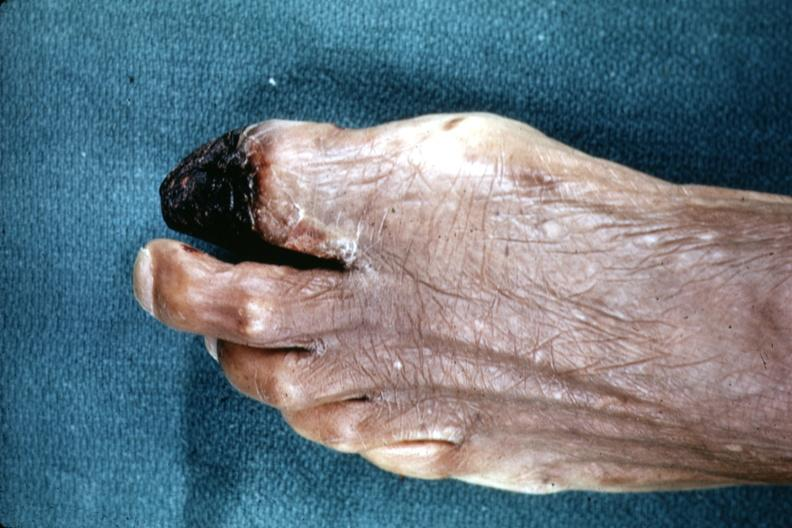re renal polycystic disease legs present?
Answer the question using a single word or phrase. No 